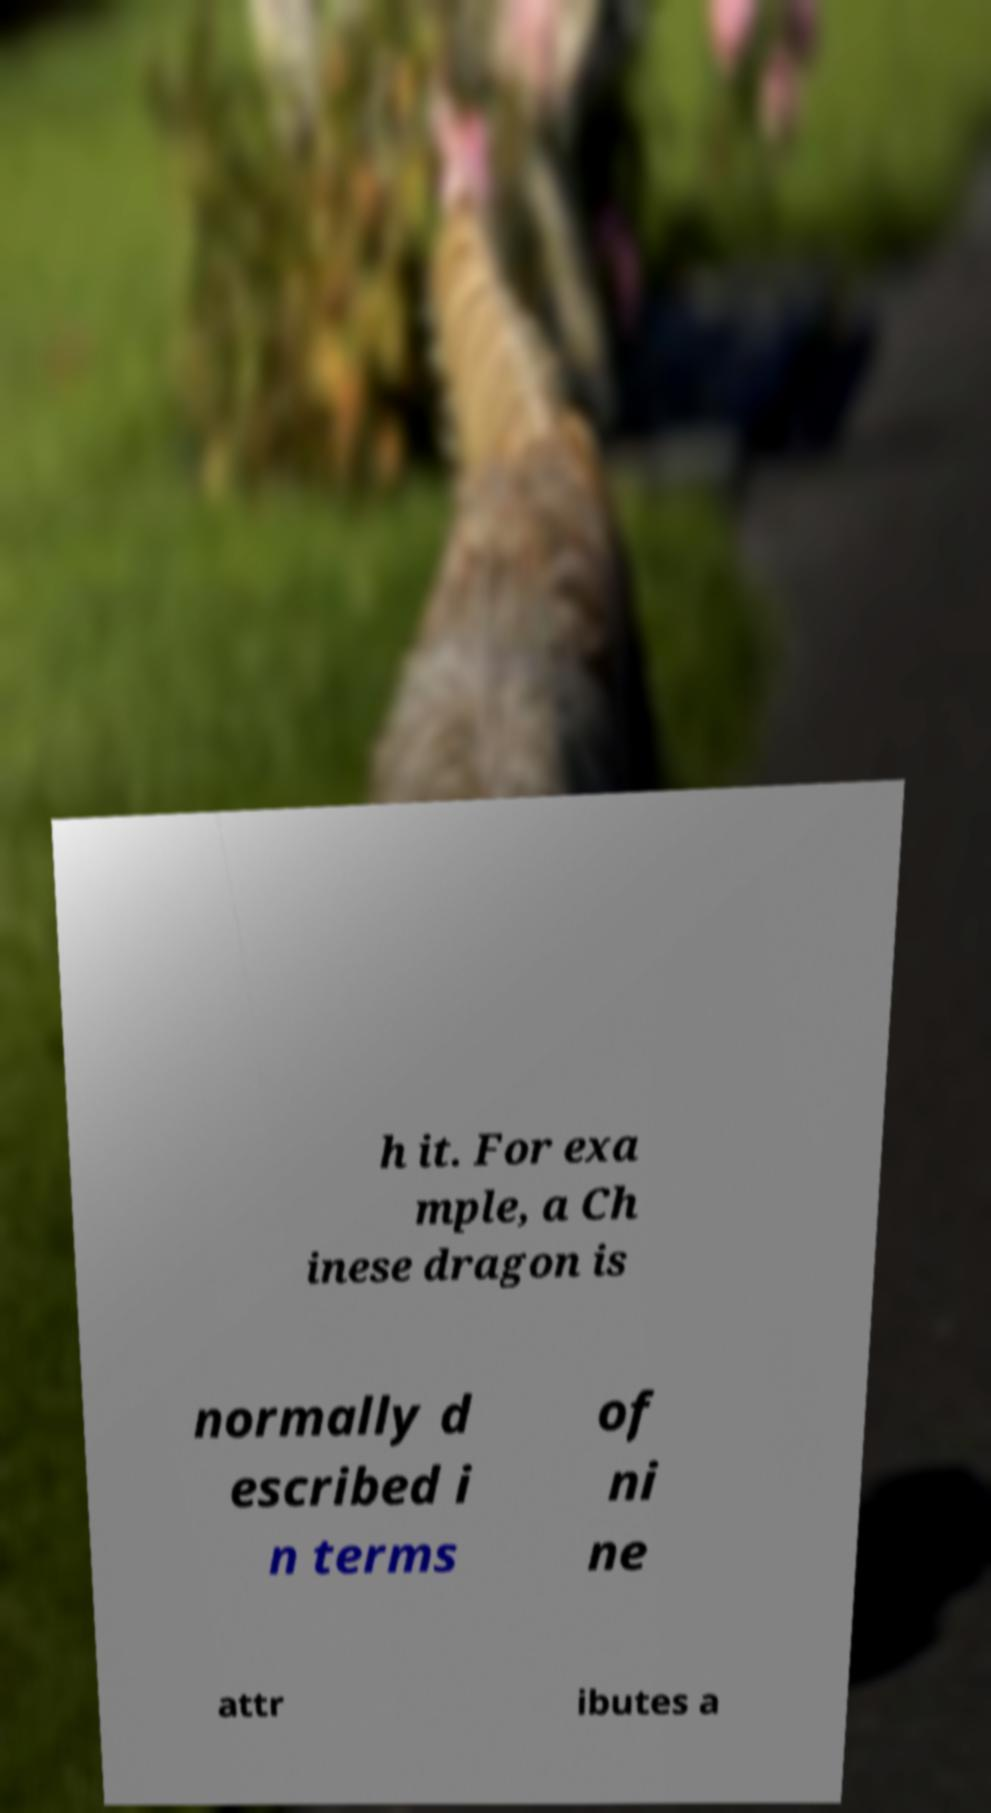What messages or text are displayed in this image? I need them in a readable, typed format. h it. For exa mple, a Ch inese dragon is normally d escribed i n terms of ni ne attr ibutes a 